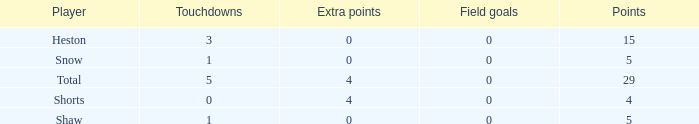What is the total number of field goals a player had when there were more than 0 extra points and there were 5 touchdowns? 1.0. 